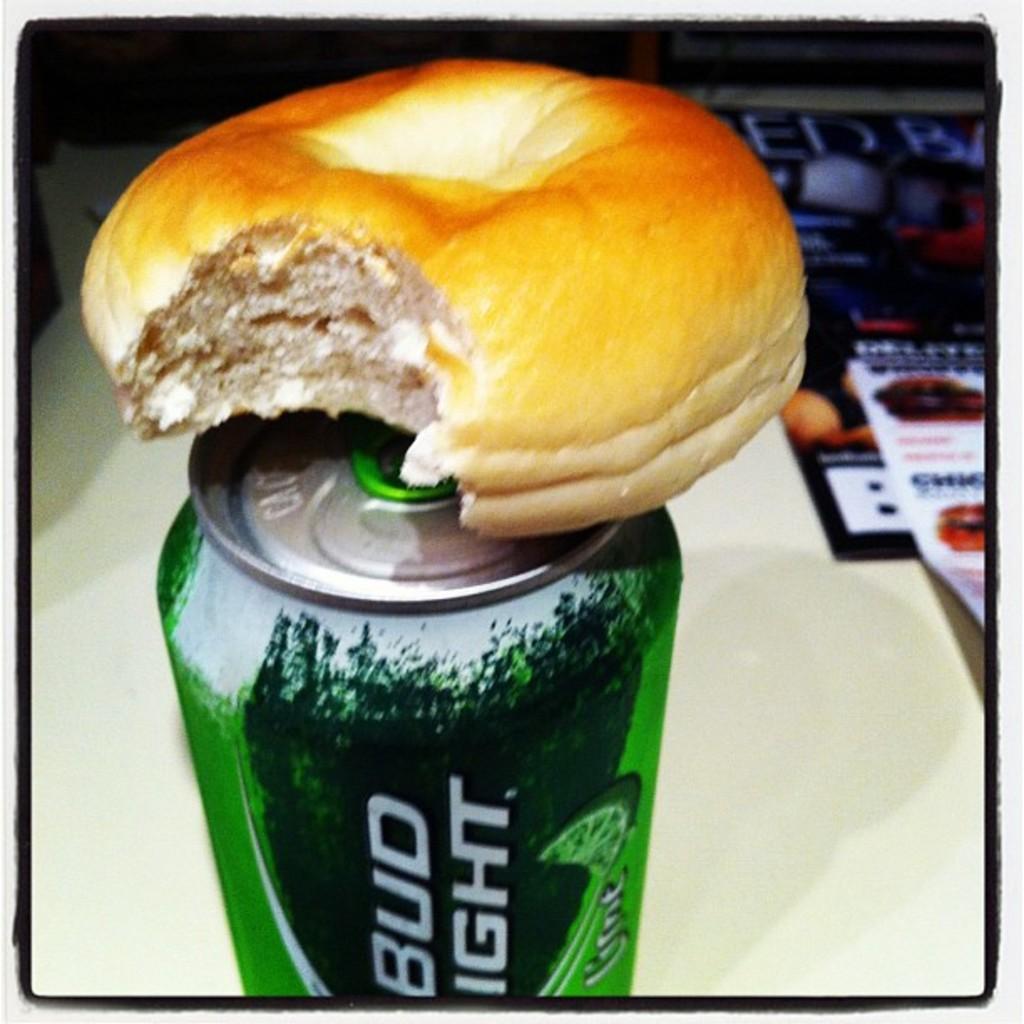How would you summarize this image in a sentence or two? In this image, we can see a tin. On top of that there is a bun. Background we can see a white surface. Here we can see few magazines and some objects. 